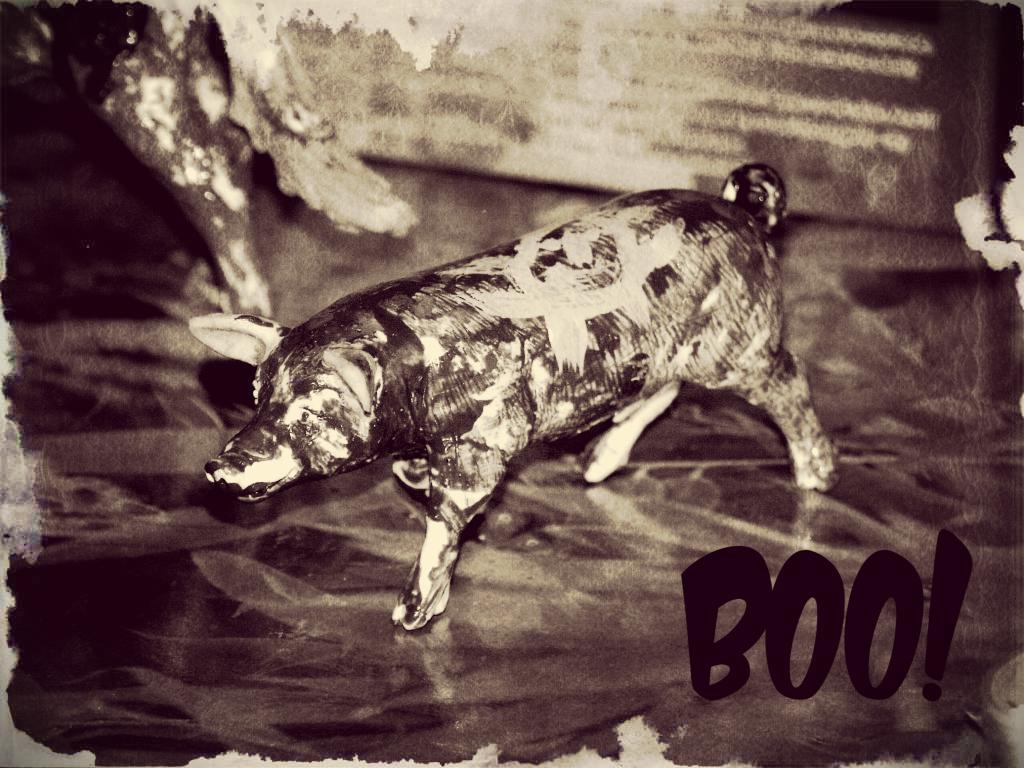What type of image is the subject of the poster? The image is a pig painting on the poster. What else can be found on the poster besides the pig painting? There is text on the poster. What color is the pig's stomach in the poster? There is no pig's stomach visible in the poster, as it is a painting of a pig, not a photograph. 